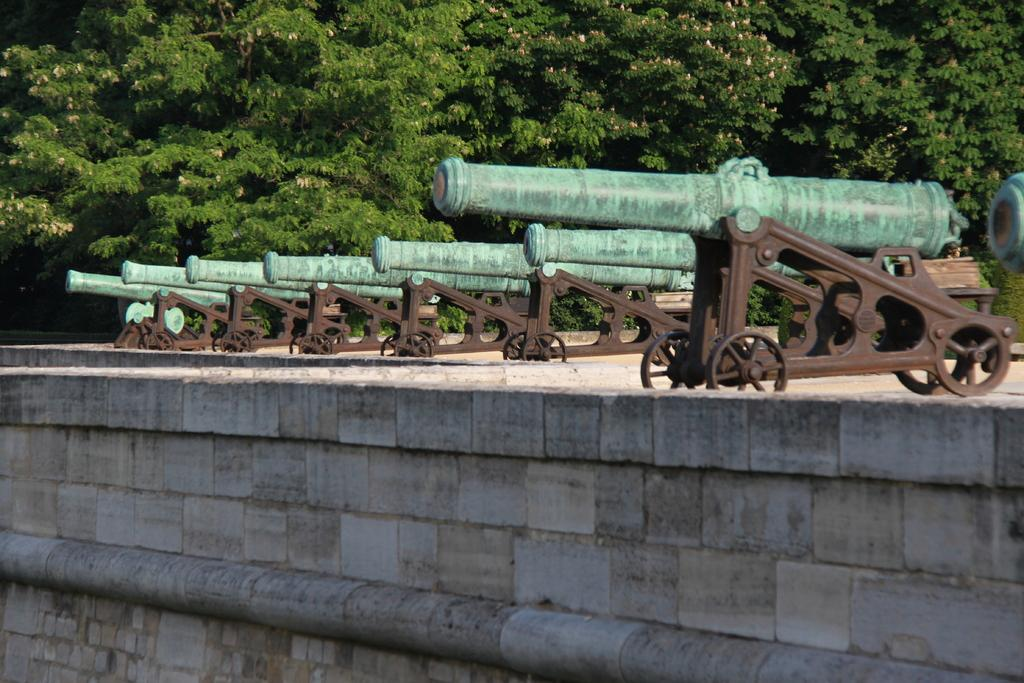What objects are on the floor in the image? There are cannons on the floor in the image. What is visible in the background of the image? There is a wall visible in the image. What type of vegetation can be seen in the image? There are trees in the image. Can you see a kitty smiling in the image? There is no kitty or smile present in the image. What type of brass material can be seen in the image? There is no brass material mentioned or visible in the image. 